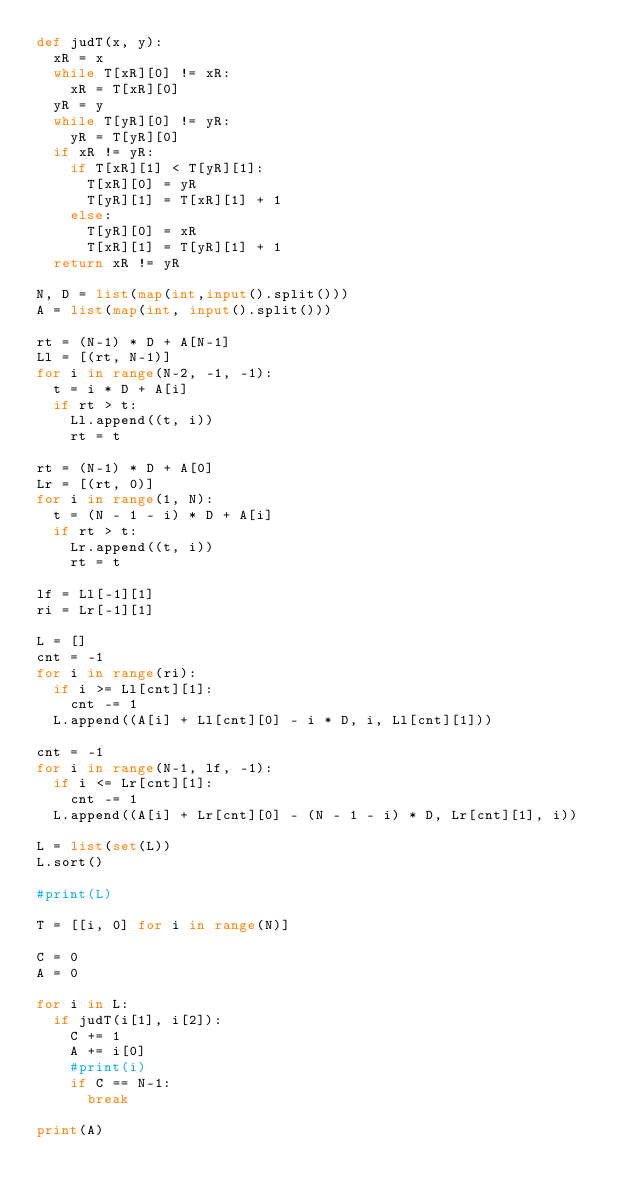<code> <loc_0><loc_0><loc_500><loc_500><_Python_>def judT(x, y):
  xR = x
  while T[xR][0] != xR:
    xR = T[xR][0]
  yR = y
  while T[yR][0] != yR:
    yR = T[yR][0]
  if xR != yR:
    if T[xR][1] < T[yR][1]:
      T[xR][0] = yR
      T[yR][1] = T[xR][1] + 1
    else:
      T[yR][0] = xR
      T[xR][1] = T[yR][1] + 1
  return xR != yR

N, D = list(map(int,input().split()))
A = list(map(int, input().split()))

rt = (N-1) * D + A[N-1]
Ll = [(rt, N-1)]
for i in range(N-2, -1, -1):
  t = i * D + A[i]
  if rt > t:
    Ll.append((t, i))
    rt = t
    
rt = (N-1) * D + A[0]
Lr = [(rt, 0)]
for i in range(1, N):
  t = (N - 1 - i) * D + A[i]
  if rt > t:
    Lr.append((t, i))
    rt = t

lf = Ll[-1][1]
ri = Lr[-1][1]

L = []
cnt = -1
for i in range(ri):
  if i >= Ll[cnt][1]:
    cnt -= 1
  L.append((A[i] + Ll[cnt][0] - i * D, i, Ll[cnt][1]))

cnt = -1
for i in range(N-1, lf, -1):
  if i <= Lr[cnt][1]:
    cnt -= 1
  L.append((A[i] + Lr[cnt][0] - (N - 1 - i) * D, Lr[cnt][1], i))

L = list(set(L))
L.sort()

#print(L)

T = [[i, 0] for i in range(N)]
 
C = 0
A = 0
 
for i in L:
  if judT(i[1], i[2]):
    C += 1
    A += i[0]
    #print(i)
    if C == N-1:
      break
 
print(A)
</code> 